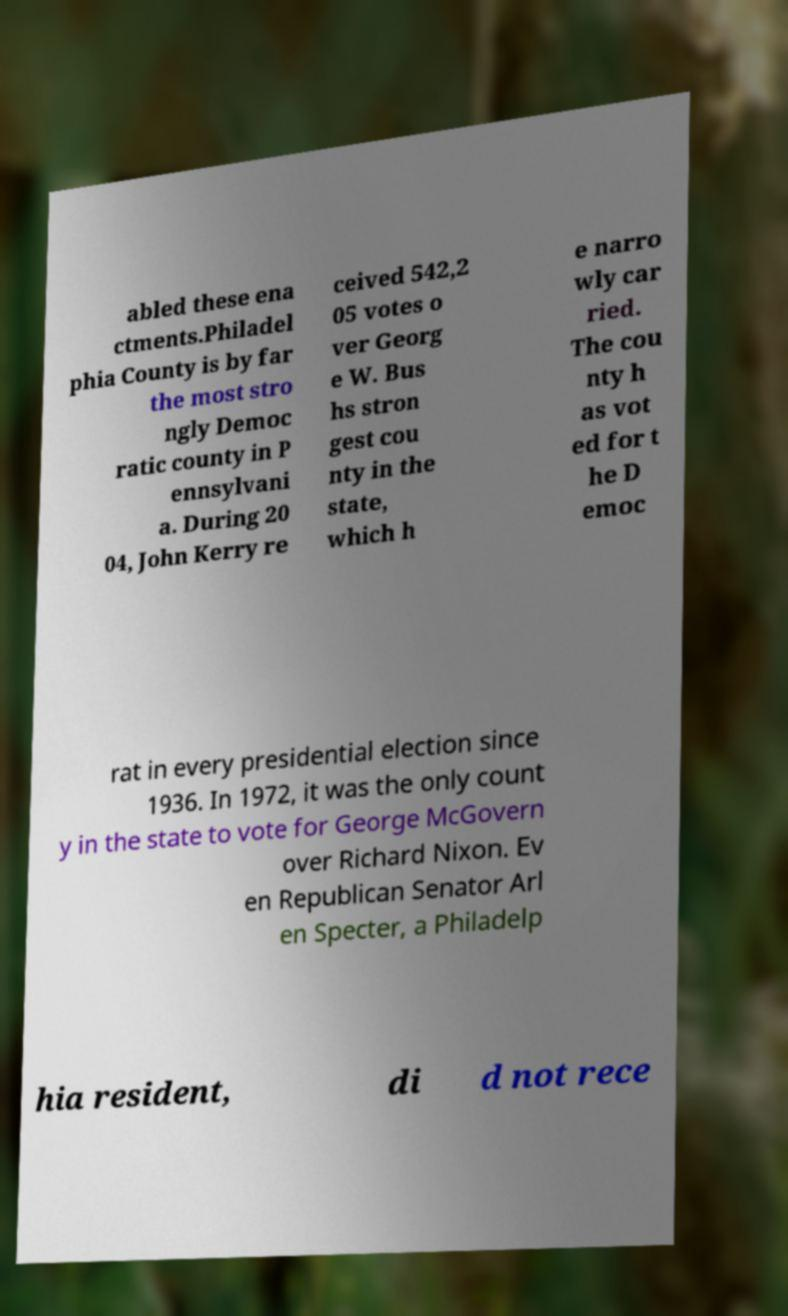Could you extract and type out the text from this image? abled these ena ctments.Philadel phia County is by far the most stro ngly Democ ratic county in P ennsylvani a. During 20 04, John Kerry re ceived 542,2 05 votes o ver Georg e W. Bus hs stron gest cou nty in the state, which h e narro wly car ried. The cou nty h as vot ed for t he D emoc rat in every presidential election since 1936. In 1972, it was the only count y in the state to vote for George McGovern over Richard Nixon. Ev en Republican Senator Arl en Specter, a Philadelp hia resident, di d not rece 